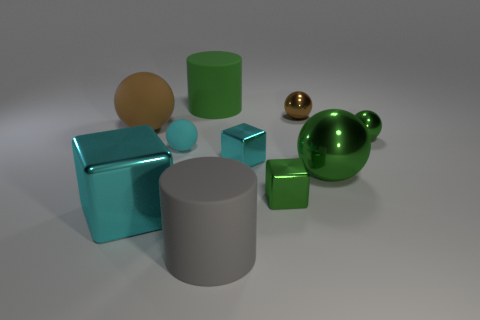What number of things are large gray objects or tiny green metal blocks?
Offer a very short reply. 2. Are there an equal number of big green shiny balls left of the big green metallic object and big purple spheres?
Make the answer very short. Yes. Is there a small green shiny cube behind the ball that is in front of the block behind the small green metal cube?
Your answer should be compact. No. What color is the other cylinder that is made of the same material as the large green cylinder?
Your answer should be compact. Gray. There is a small ball to the left of the green rubber thing; is it the same color as the large rubber ball?
Provide a succinct answer. No. How many cubes are either big brown things or big green matte objects?
Your answer should be very brief. 0. What size is the cylinder that is in front of the tiny green shiny object that is behind the large thing on the right side of the gray object?
Make the answer very short. Large. The cyan metal object that is the same size as the gray rubber cylinder is what shape?
Your answer should be very brief. Cube. What is the shape of the large cyan object?
Your answer should be very brief. Cube. Are the small cyan object that is on the left side of the large green cylinder and the large gray cylinder made of the same material?
Give a very brief answer. Yes. 